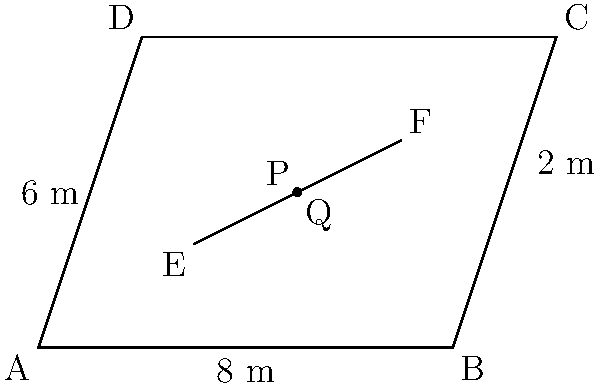In a local Nepali cinema hall, the seating layout forms a parallelogram ABCD as shown. Two aisles represented by line EF intersect the diagonals of the parallelogram. If the base of the parallelogram is 8 meters and its height is 6 meters, what is the area of the smaller parallelogram PEFQ formed by the intersecting lines? Let's approach this step-by-step:

1) First, we need to find the area of the entire parallelogram ABCD.
   Area of parallelogram = base × height
   Area of ABCD = $8 \times 6 = 48$ square meters

2) Now, we need to find the ratio of the smaller parallelogram to the larger one.
   In a parallelogram, any line parallel to a side divides the other two sides proportionally.

3) Let's focus on triangle ABC:
   Line EF divides AC and BC in the same ratio.
   From the diagram, it appears that EF divides AC in the ratio 1:2 (approximately).

4) This means that the area of parallelogram PEFQ is $\frac{1}{3}$ of the area of ABCD.

5) Therefore, the area of PEFQ = $\frac{1}{3} \times 48 = 16$ square meters.

This layout design, reminiscent of traditional Nepali theaters, efficiently utilizes space while providing clear sightlines for moviegoers enjoying local productions.
Answer: 16 square meters 